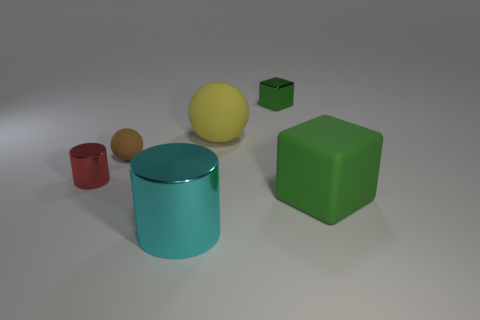Add 2 big cyan metal cylinders. How many objects exist? 8 Subtract all brown spheres. How many spheres are left? 1 Subtract 1 yellow balls. How many objects are left? 5 Subtract all yellow blocks. Subtract all purple cylinders. How many blocks are left? 2 Subtract all tiny green metallic cubes. Subtract all large yellow balls. How many objects are left? 4 Add 5 cyan cylinders. How many cyan cylinders are left? 6 Add 1 red metallic cylinders. How many red metallic cylinders exist? 2 